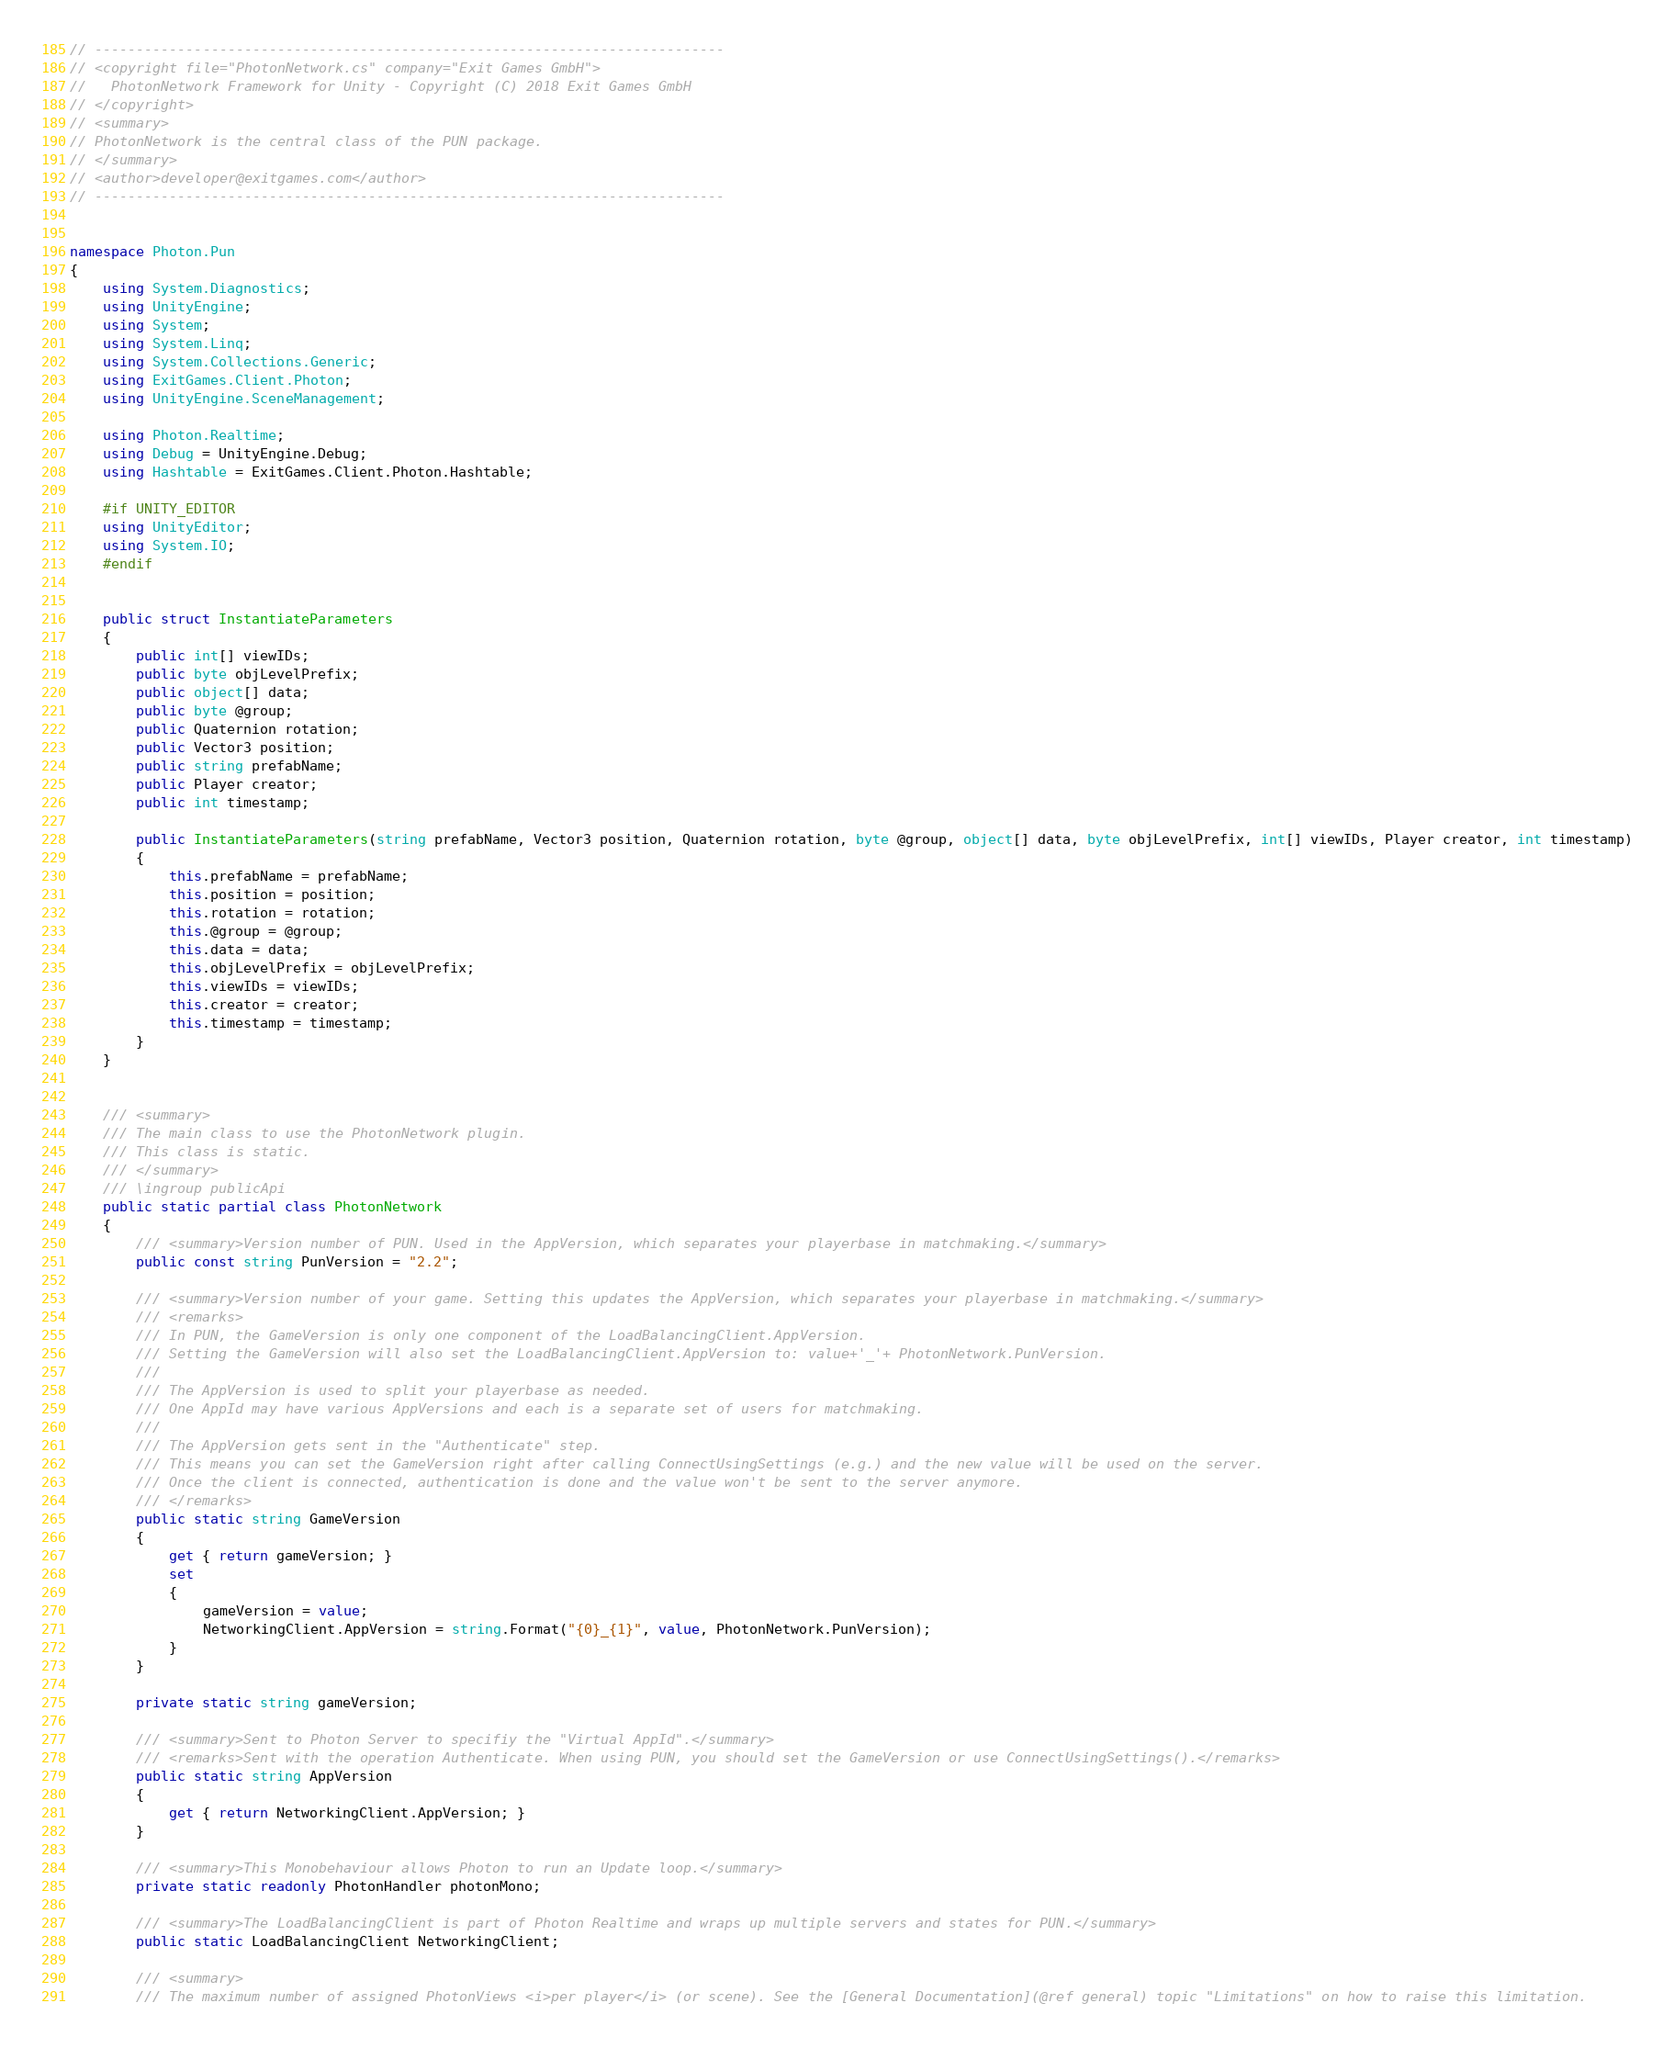Convert code to text. <code><loc_0><loc_0><loc_500><loc_500><_C#_>// ----------------------------------------------------------------------------
// <copyright file="PhotonNetwork.cs" company="Exit Games GmbH">
//   PhotonNetwork Framework for Unity - Copyright (C) 2018 Exit Games GmbH
// </copyright>
// <summary>
// PhotonNetwork is the central class of the PUN package.
// </summary>
// <author>developer@exitgames.com</author>
// ----------------------------------------------------------------------------


namespace Photon.Pun
{
    using System.Diagnostics;
    using UnityEngine;
    using System;
    using System.Linq;
    using System.Collections.Generic;
    using ExitGames.Client.Photon;
    using UnityEngine.SceneManagement;

    using Photon.Realtime;
    using Debug = UnityEngine.Debug;
    using Hashtable = ExitGames.Client.Photon.Hashtable;

    #if UNITY_EDITOR
    using UnityEditor;
    using System.IO;
    #endif


    public struct InstantiateParameters
    {
        public int[] viewIDs;
        public byte objLevelPrefix;
        public object[] data;
        public byte @group;
        public Quaternion rotation;
        public Vector3 position;
        public string prefabName;
        public Player creator;
        public int timestamp;

        public InstantiateParameters(string prefabName, Vector3 position, Quaternion rotation, byte @group, object[] data, byte objLevelPrefix, int[] viewIDs, Player creator, int timestamp)
        {
            this.prefabName = prefabName;
            this.position = position;
            this.rotation = rotation;
            this.@group = @group;
            this.data = data;
            this.objLevelPrefix = objLevelPrefix;
            this.viewIDs = viewIDs;
            this.creator = creator;
            this.timestamp = timestamp;
        }
    }


    /// <summary>
    /// The main class to use the PhotonNetwork plugin.
    /// This class is static.
    /// </summary>
    /// \ingroup publicApi
    public static partial class PhotonNetwork
    {
        /// <summary>Version number of PUN. Used in the AppVersion, which separates your playerbase in matchmaking.</summary>
        public const string PunVersion = "2.2";

        /// <summary>Version number of your game. Setting this updates the AppVersion, which separates your playerbase in matchmaking.</summary>
        /// <remarks>
        /// In PUN, the GameVersion is only one component of the LoadBalancingClient.AppVersion.
        /// Setting the GameVersion will also set the LoadBalancingClient.AppVersion to: value+'_'+ PhotonNetwork.PunVersion.
        ///
        /// The AppVersion is used to split your playerbase as needed.
        /// One AppId may have various AppVersions and each is a separate set of users for matchmaking.
        ///
        /// The AppVersion gets sent in the "Authenticate" step.
        /// This means you can set the GameVersion right after calling ConnectUsingSettings (e.g.) and the new value will be used on the server.
        /// Once the client is connected, authentication is done and the value won't be sent to the server anymore.
        /// </remarks>
        public static string GameVersion
        {
            get { return gameVersion; }
            set
            {
                gameVersion = value;
                NetworkingClient.AppVersion = string.Format("{0}_{1}", value, PhotonNetwork.PunVersion);
            }
        }

        private static string gameVersion;

        /// <summary>Sent to Photon Server to specifiy the "Virtual AppId".</summary>
        /// <remarks>Sent with the operation Authenticate. When using PUN, you should set the GameVersion or use ConnectUsingSettings().</remarks>
        public static string AppVersion
        {
            get { return NetworkingClient.AppVersion; }
        }

        /// <summary>This Monobehaviour allows Photon to run an Update loop.</summary>
        private static readonly PhotonHandler photonMono;

        /// <summary>The LoadBalancingClient is part of Photon Realtime and wraps up multiple servers and states for PUN.</summary>
        public static LoadBalancingClient NetworkingClient;

        /// <summary>
        /// The maximum number of assigned PhotonViews <i>per player</i> (or scene). See the [General Documentation](@ref general) topic "Limitations" on how to raise this limitation.</code> 